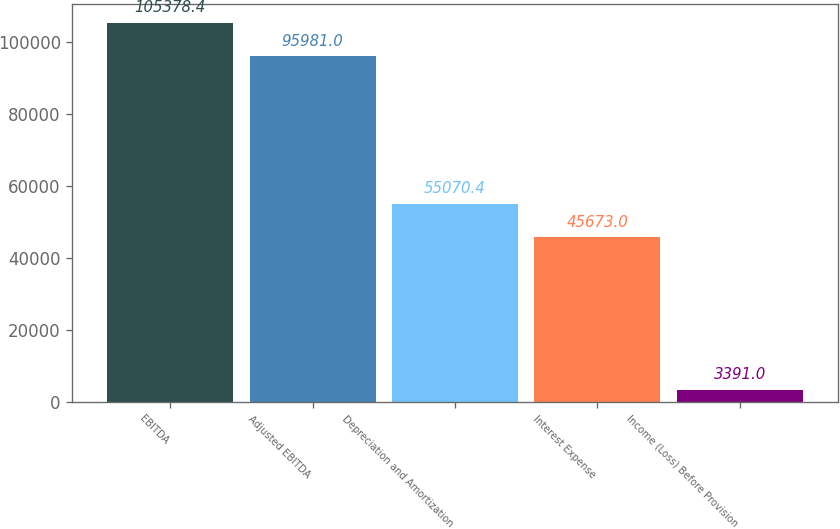<chart> <loc_0><loc_0><loc_500><loc_500><bar_chart><fcel>EBITDA<fcel>Adjusted EBITDA<fcel>Depreciation and Amortization<fcel>Interest Expense<fcel>Income (Loss) Before Provision<nl><fcel>105378<fcel>95981<fcel>55070.4<fcel>45673<fcel>3391<nl></chart> 